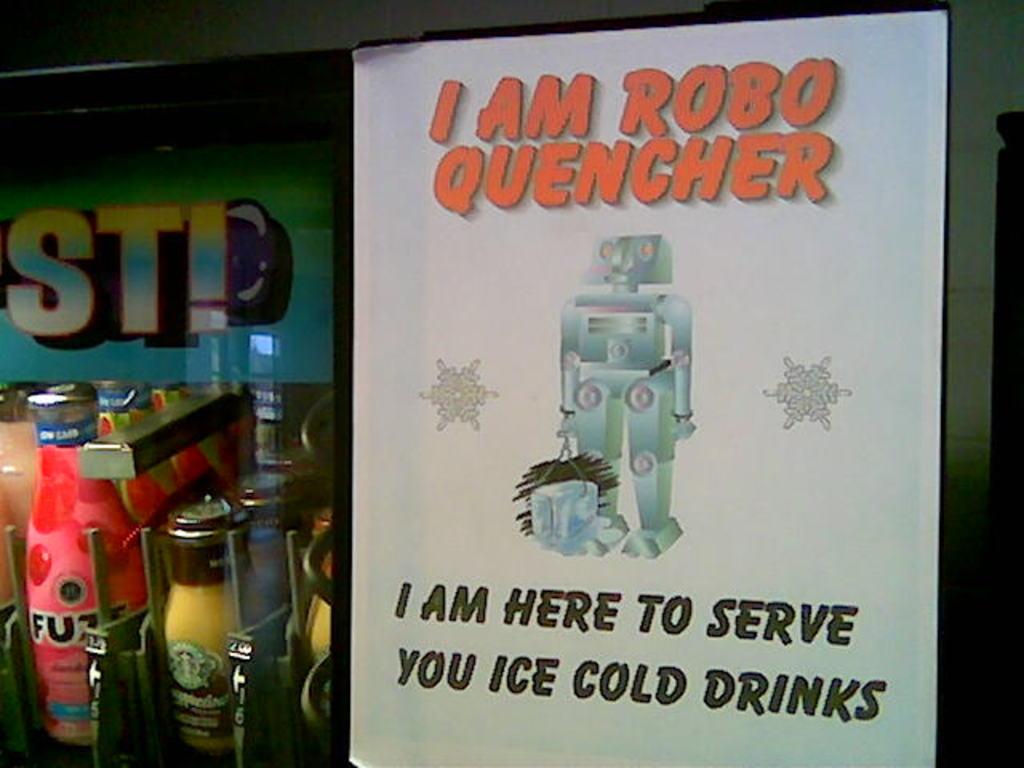What does robo quencher serve you?
Provide a succinct answer. Ice cold drinks. 